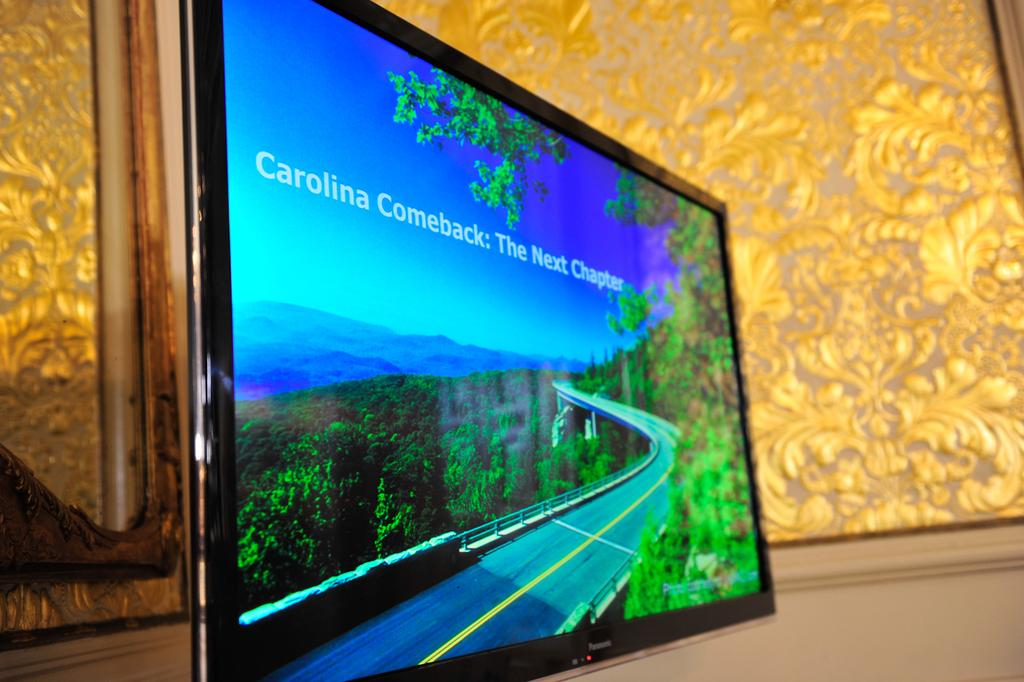<image>
Summarize the visual content of the image. A tablet leaning on a wall with the screen reading Carolina Comeback:The Next Chapter on a scenic road with a trees surrounding. 